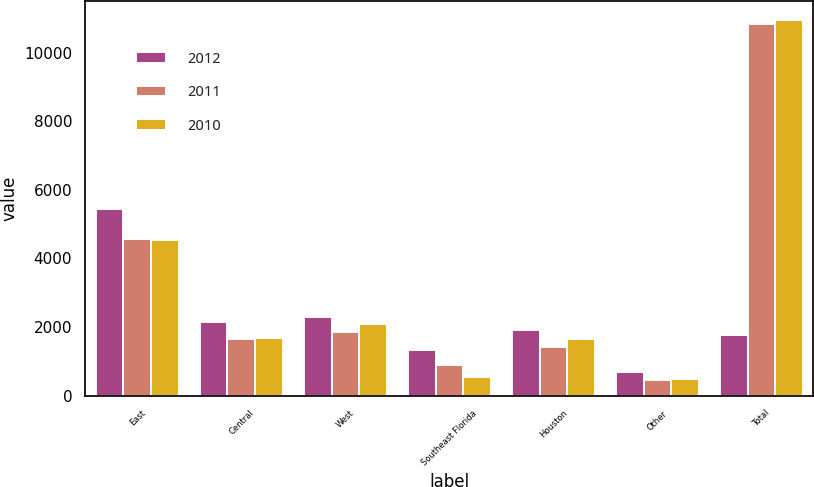Convert chart to OTSL. <chart><loc_0><loc_0><loc_500><loc_500><stacked_bar_chart><ecel><fcel>East<fcel>Central<fcel>West<fcel>Southeast Florida<fcel>Houston<fcel>Other<fcel>Total<nl><fcel>2012<fcel>5440<fcel>2154<fcel>2301<fcel>1314<fcel>1917<fcel>676<fcel>1764<nl><fcel>2011<fcel>4576<fcel>1661<fcel>1846<fcel>904<fcel>1411<fcel>447<fcel>10845<nl><fcel>2010<fcel>4539<fcel>1682<fcel>2079<fcel>536<fcel>1645<fcel>474<fcel>10955<nl></chart> 